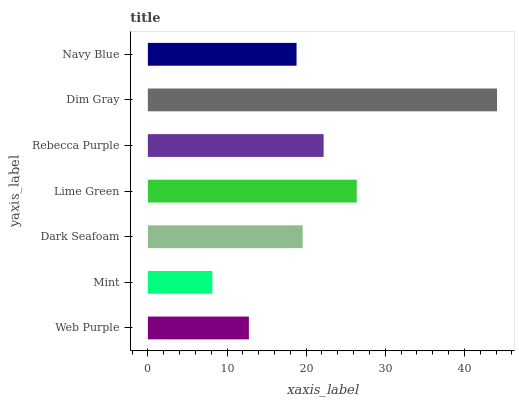Is Mint the minimum?
Answer yes or no. Yes. Is Dim Gray the maximum?
Answer yes or no. Yes. Is Dark Seafoam the minimum?
Answer yes or no. No. Is Dark Seafoam the maximum?
Answer yes or no. No. Is Dark Seafoam greater than Mint?
Answer yes or no. Yes. Is Mint less than Dark Seafoam?
Answer yes or no. Yes. Is Mint greater than Dark Seafoam?
Answer yes or no. No. Is Dark Seafoam less than Mint?
Answer yes or no. No. Is Dark Seafoam the high median?
Answer yes or no. Yes. Is Dark Seafoam the low median?
Answer yes or no. Yes. Is Lime Green the high median?
Answer yes or no. No. Is Dim Gray the low median?
Answer yes or no. No. 